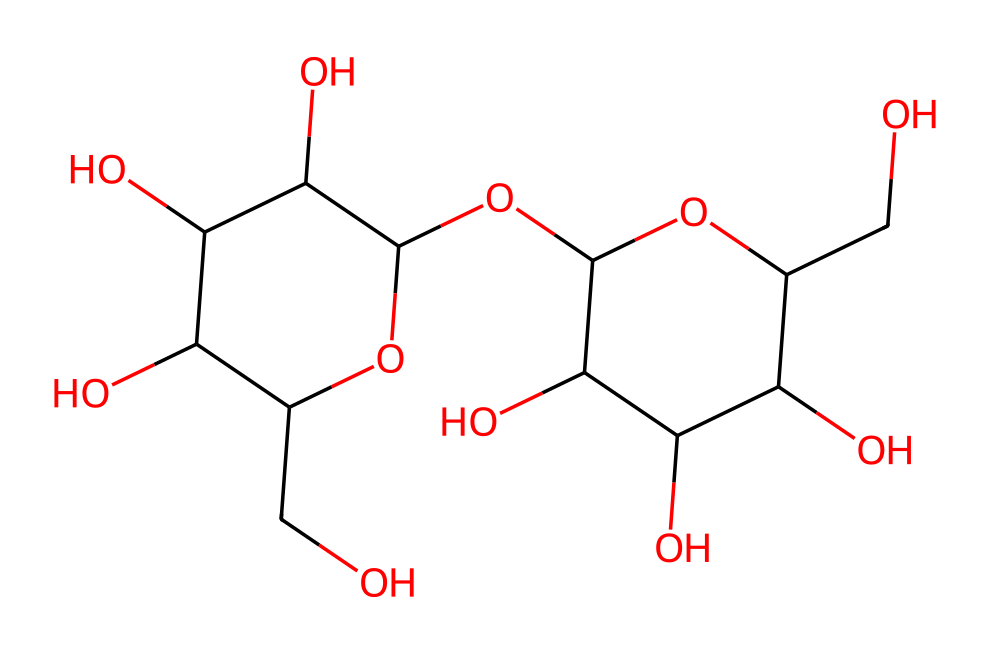How many carbon atoms are in the structure? By examining the SMILES representation, we count all the carbon atoms (C) present. The structure reveals that there are 15 carbon atoms in total.
Answer: 15 What type of chemical structure is represented here? This structure corresponds to a polysaccharide, specifically starch, which is a carbohydrate made up of glucose units.
Answer: polysaccharide How many hydroxyl (OH) groups are present? In the structure, we identify -OH (hydroxyl) groups by counting the instances where oxygen is attached to hydrogen. There are 5 hydroxyl groups in total.
Answer: 5 Is this compound soluble in water? Starch is generally soluble in water due to the presence of multiple hydroxyl groups which can form hydrogen bonds with water molecules, leading to its solubility.
Answer: yes What is the main purpose of using this substance in fabric stiffeners? Starch acts as a non-electrolyte that provides stiffness and helps improve the structure and finish of fabrics.
Answer: stiffness 